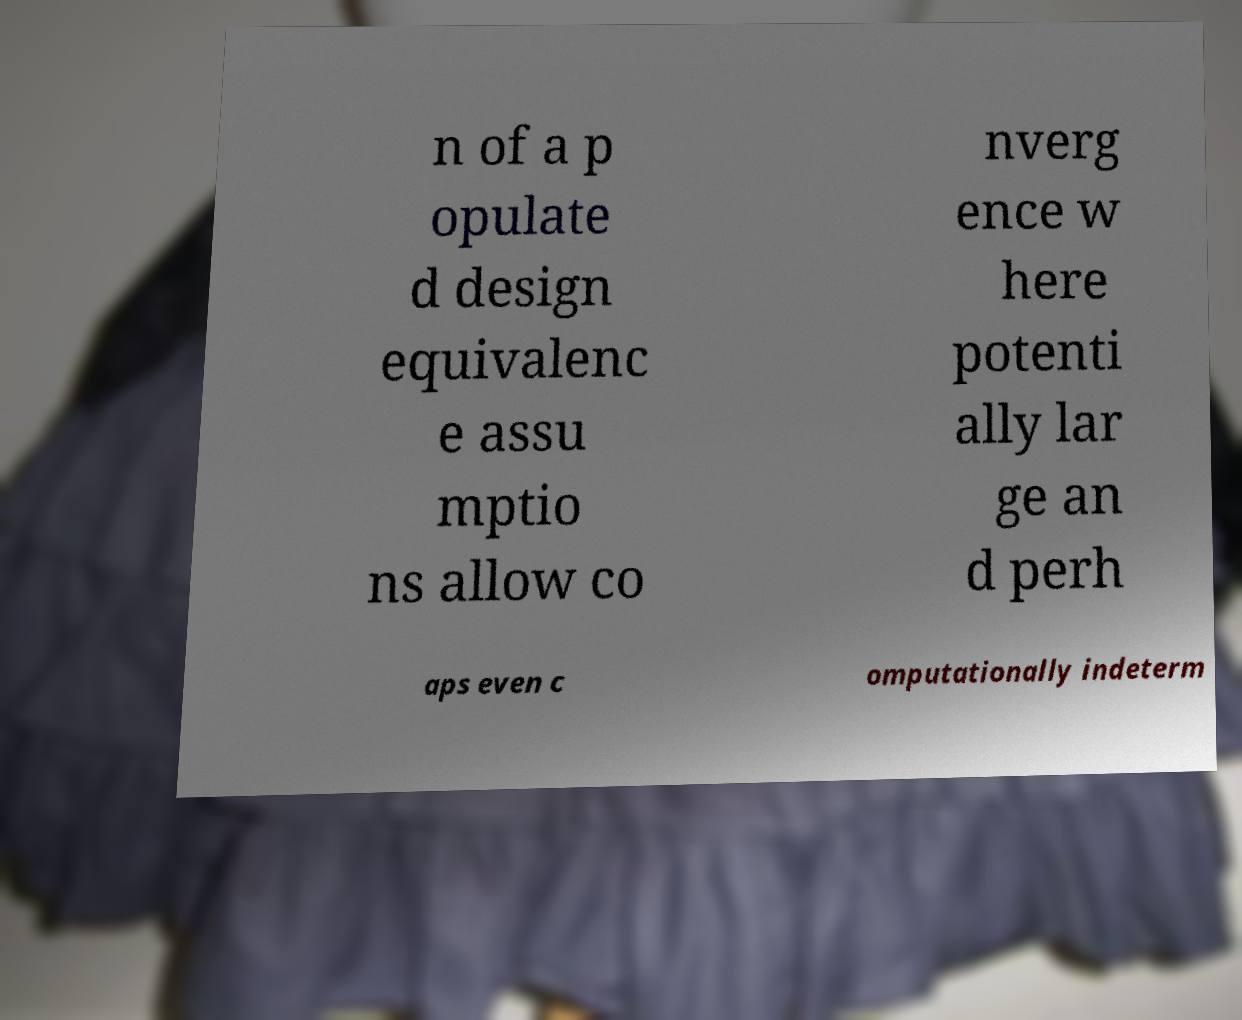For documentation purposes, I need the text within this image transcribed. Could you provide that? n of a p opulate d design equivalenc e assu mptio ns allow co nverg ence w here potenti ally lar ge an d perh aps even c omputationally indeterm 